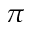Convert formula to latex. <formula><loc_0><loc_0><loc_500><loc_500>\pi</formula> 